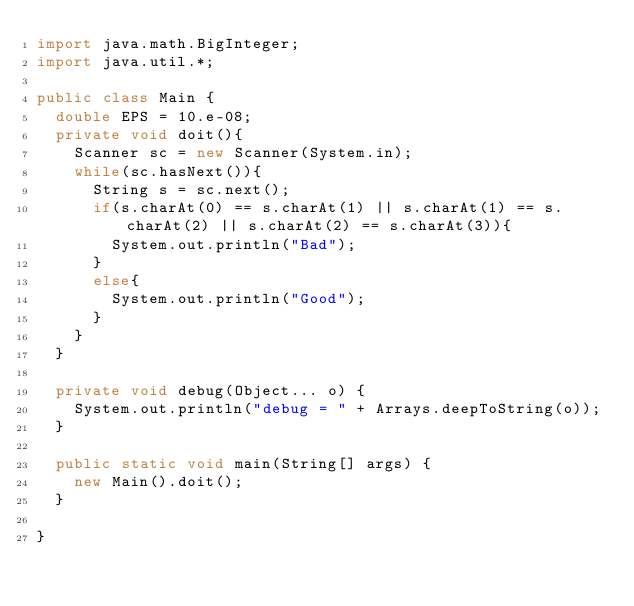Convert code to text. <code><loc_0><loc_0><loc_500><loc_500><_Java_>import java.math.BigInteger;
import java.util.*;

public class Main {
	double EPS = 10.e-08;
	private void doit(){
		Scanner sc = new Scanner(System.in);
		while(sc.hasNext()){
			String s = sc.next();
			if(s.charAt(0) == s.charAt(1) || s.charAt(1) == s.charAt(2) || s.charAt(2) == s.charAt(3)){
				System.out.println("Bad");
			}
			else{
				System.out.println("Good");
			}
		}
	}

	private void debug(Object... o) {
		System.out.println("debug = " + Arrays.deepToString(o));
	}

	public static void main(String[] args) {
		new Main().doit();
	}

}
</code> 